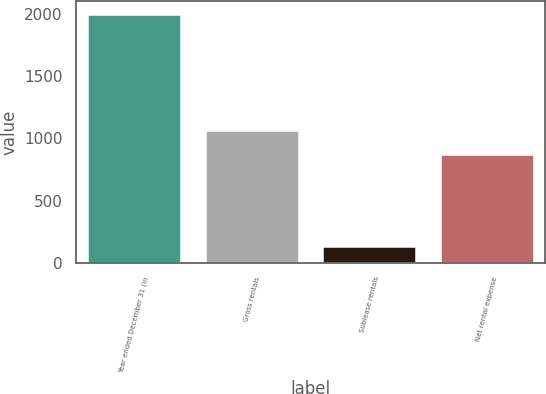<chart> <loc_0><loc_0><loc_500><loc_500><bar_chart><fcel>Year ended December 31 (in<fcel>Gross rentals<fcel>Sublease rentals<fcel>Net rental expense<nl><fcel>2002<fcel>1064.8<fcel>134<fcel>878<nl></chart> 